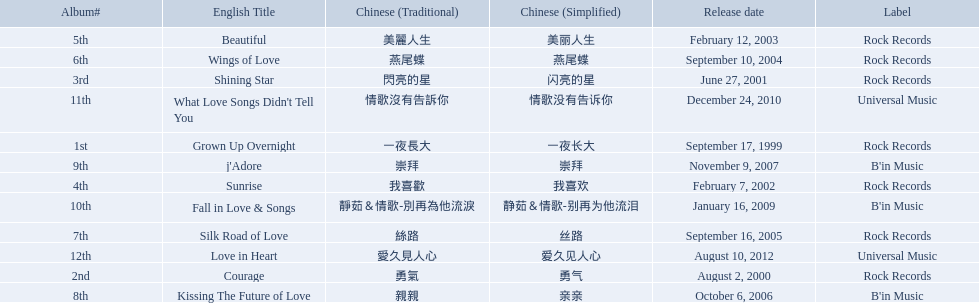Which songs did b'in music produce? Kissing The Future of Love, j'Adore, Fall in Love & Songs. Which one was released in an even numbered year? Kissing The Future of Love. 